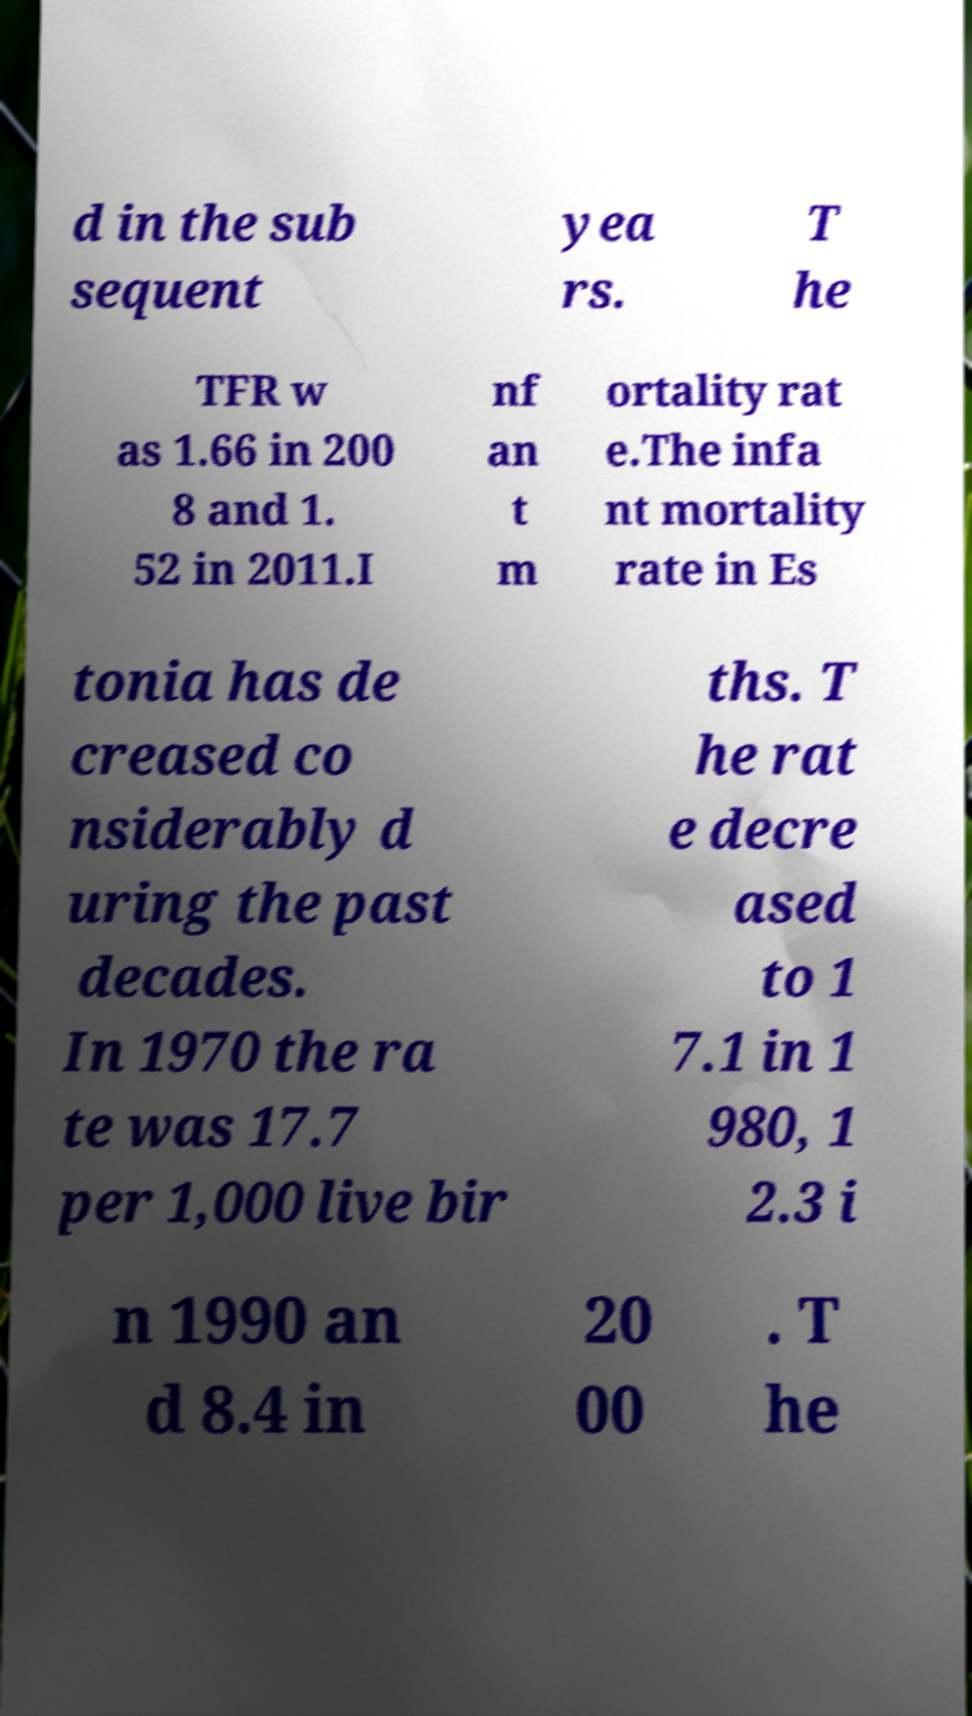What messages or text are displayed in this image? I need them in a readable, typed format. d in the sub sequent yea rs. T he TFR w as 1.66 in 200 8 and 1. 52 in 2011.I nf an t m ortality rat e.The infa nt mortality rate in Es tonia has de creased co nsiderably d uring the past decades. In 1970 the ra te was 17.7 per 1,000 live bir ths. T he rat e decre ased to 1 7.1 in 1 980, 1 2.3 i n 1990 an d 8.4 in 20 00 . T he 